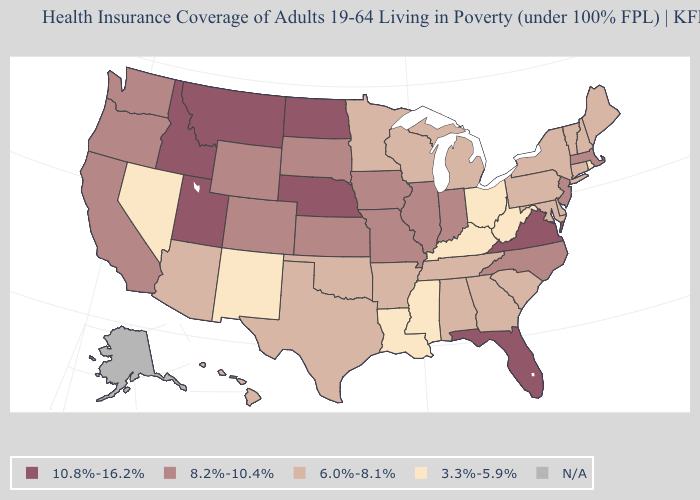Does the first symbol in the legend represent the smallest category?
Write a very short answer. No. Name the states that have a value in the range 10.8%-16.2%?
Keep it brief. Florida, Idaho, Montana, Nebraska, North Dakota, Utah, Virginia. Does Louisiana have the lowest value in the USA?
Concise answer only. Yes. Is the legend a continuous bar?
Be succinct. No. What is the value of Arizona?
Be succinct. 6.0%-8.1%. Name the states that have a value in the range 10.8%-16.2%?
Keep it brief. Florida, Idaho, Montana, Nebraska, North Dakota, Utah, Virginia. Name the states that have a value in the range 10.8%-16.2%?
Give a very brief answer. Florida, Idaho, Montana, Nebraska, North Dakota, Utah, Virginia. How many symbols are there in the legend?
Give a very brief answer. 5. What is the value of Minnesota?
Short answer required. 6.0%-8.1%. What is the highest value in states that border North Carolina?
Quick response, please. 10.8%-16.2%. Which states hav the highest value in the Northeast?
Concise answer only. Massachusetts, New Jersey. Is the legend a continuous bar?
Short answer required. No. Name the states that have a value in the range 6.0%-8.1%?
Be succinct. Alabama, Arizona, Arkansas, Connecticut, Delaware, Georgia, Hawaii, Maine, Maryland, Michigan, Minnesota, New Hampshire, New York, Oklahoma, Pennsylvania, South Carolina, Tennessee, Texas, Vermont, Wisconsin. What is the highest value in the South ?
Answer briefly. 10.8%-16.2%. 